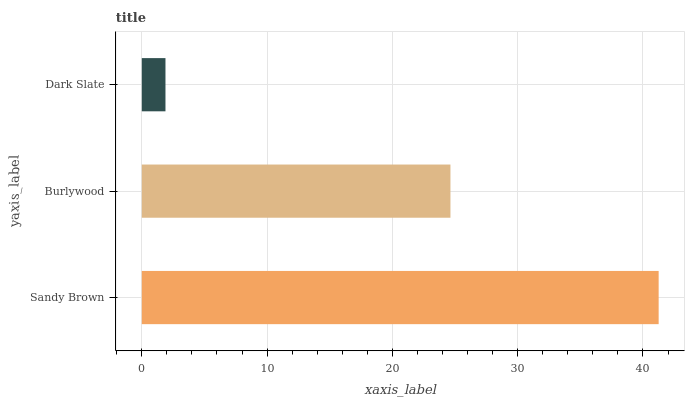Is Dark Slate the minimum?
Answer yes or no. Yes. Is Sandy Brown the maximum?
Answer yes or no. Yes. Is Burlywood the minimum?
Answer yes or no. No. Is Burlywood the maximum?
Answer yes or no. No. Is Sandy Brown greater than Burlywood?
Answer yes or no. Yes. Is Burlywood less than Sandy Brown?
Answer yes or no. Yes. Is Burlywood greater than Sandy Brown?
Answer yes or no. No. Is Sandy Brown less than Burlywood?
Answer yes or no. No. Is Burlywood the high median?
Answer yes or no. Yes. Is Burlywood the low median?
Answer yes or no. Yes. Is Dark Slate the high median?
Answer yes or no. No. Is Sandy Brown the low median?
Answer yes or no. No. 